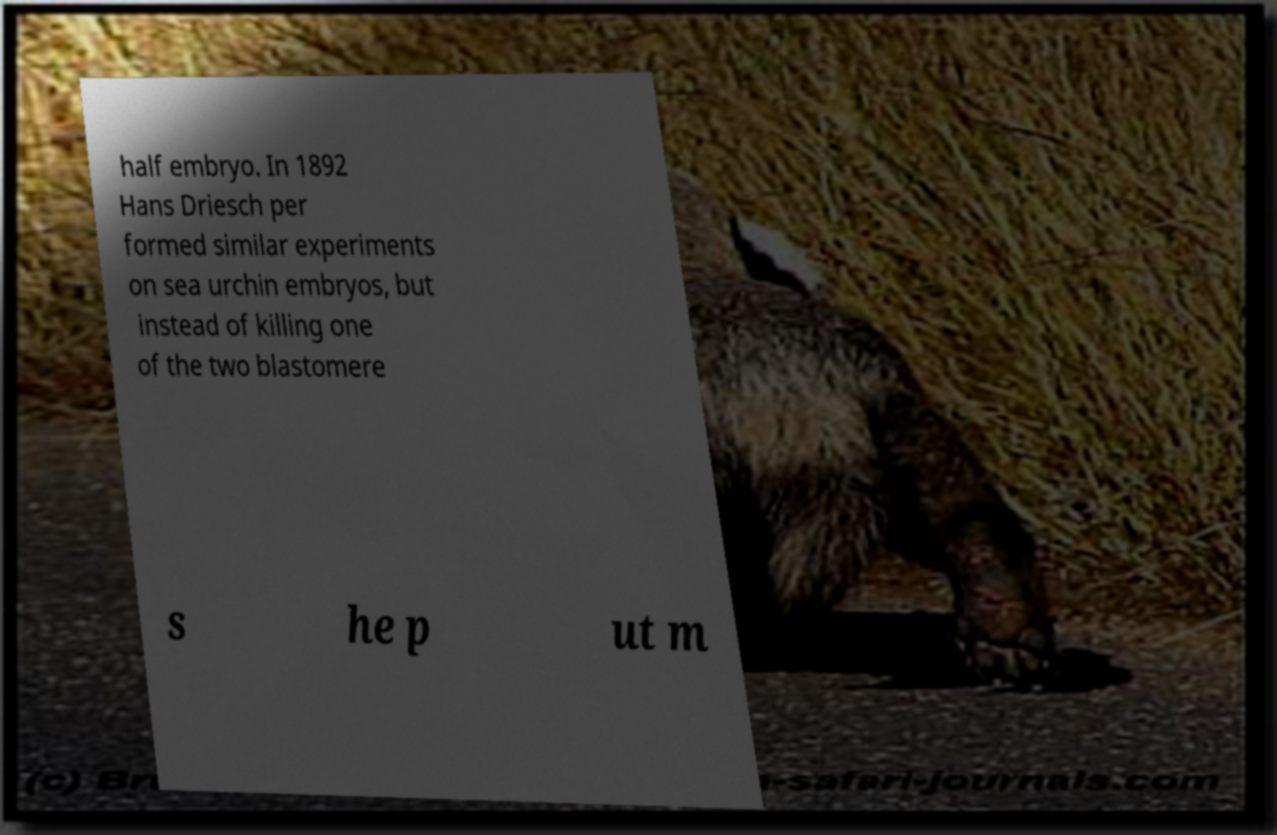Please read and relay the text visible in this image. What does it say? half embryo. In 1892 Hans Driesch per formed similar experiments on sea urchin embryos, but instead of killing one of the two blastomere s he p ut m 